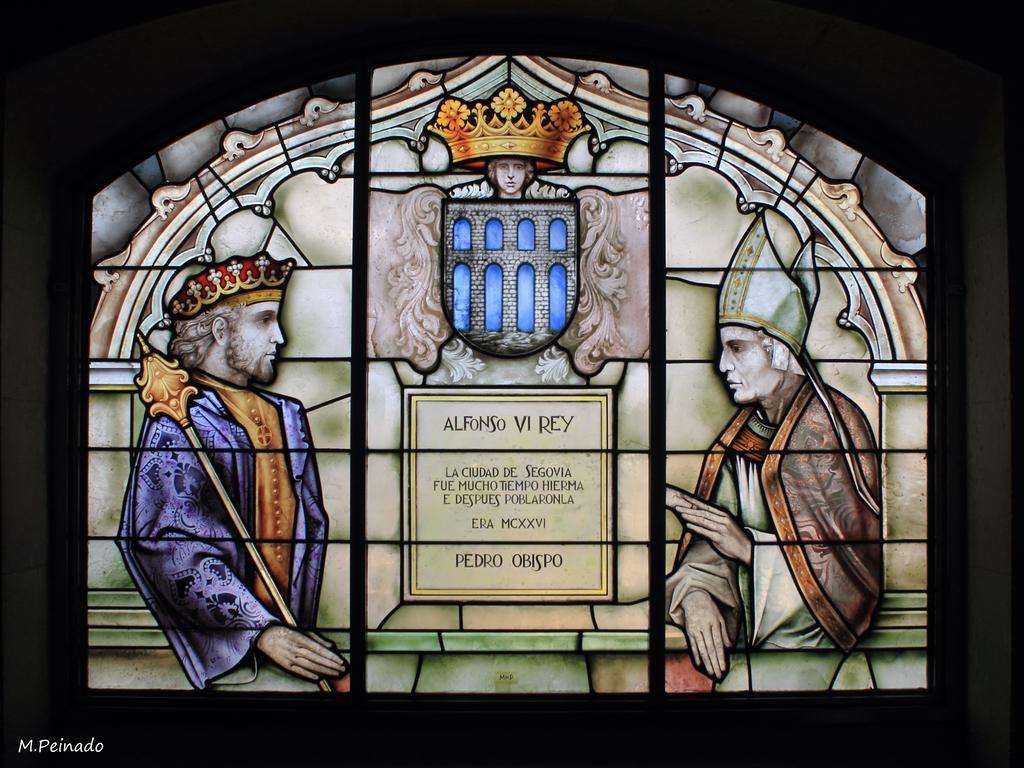Who said the quote in the picture?
Provide a succinct answer. Pedro obispo. Who is the artist?
Keep it short and to the point. Alfonso vi rey. 